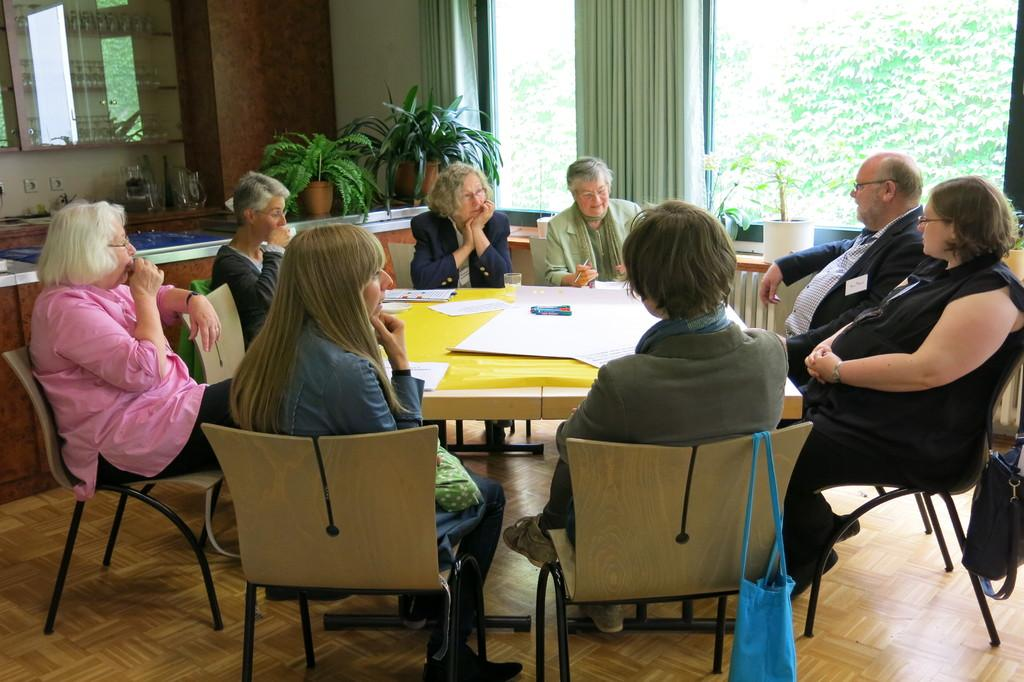What type of structure can be seen in the image? There is a wall in the image. What is located near the wall? There is a window in the image, and it has a curtain associated with it. What can be seen outside the window? The presence of plants suggests that there is a natural setting visible outside the window. What are the people in the image doing? There are people sitting on chairs in the image. What is on the table in the image? There is a glass and a paper on the table in the image. What type of cork can be seen in the image? There is no cork present in the image. What observation can be made about the people's behavior in the image? The provided facts do not give any information about the people's behavior, so it cannot be determined from the image. 